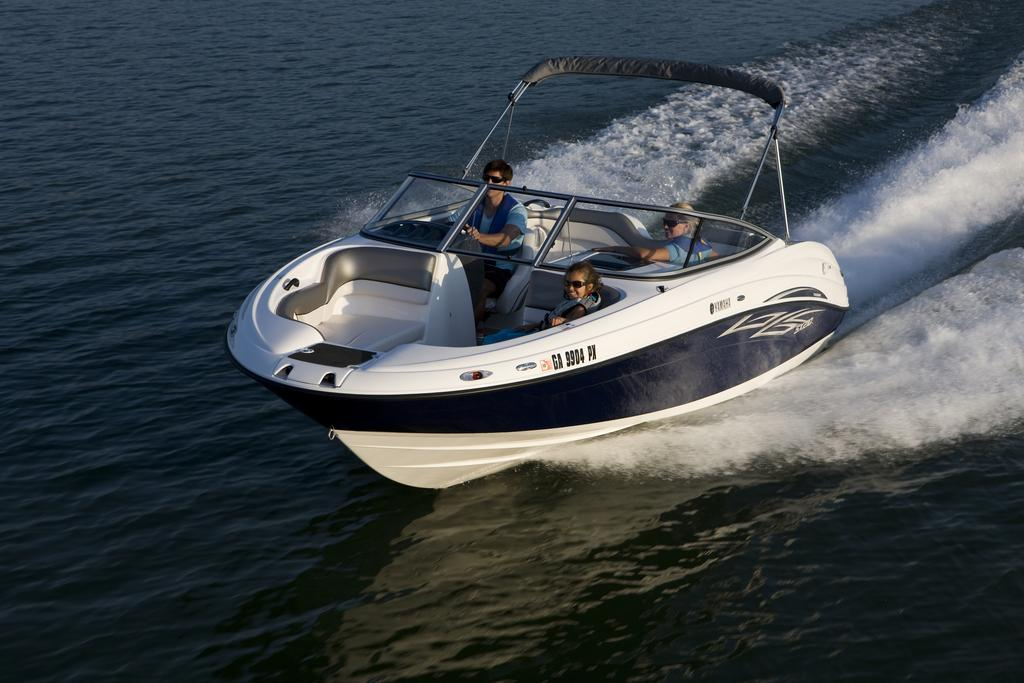How many people are in the image? There are persons in the image. What are the persons doing in the image? The persons are sitting in a steamer. Where is the steamer located? The steamer is on the sea. What type of boats can be seen in the image? There are no boats visible in the image; it features a steamer on the sea. What achievements have the persons in the image accomplished? There is no information about the achievements of the persons in the image. 